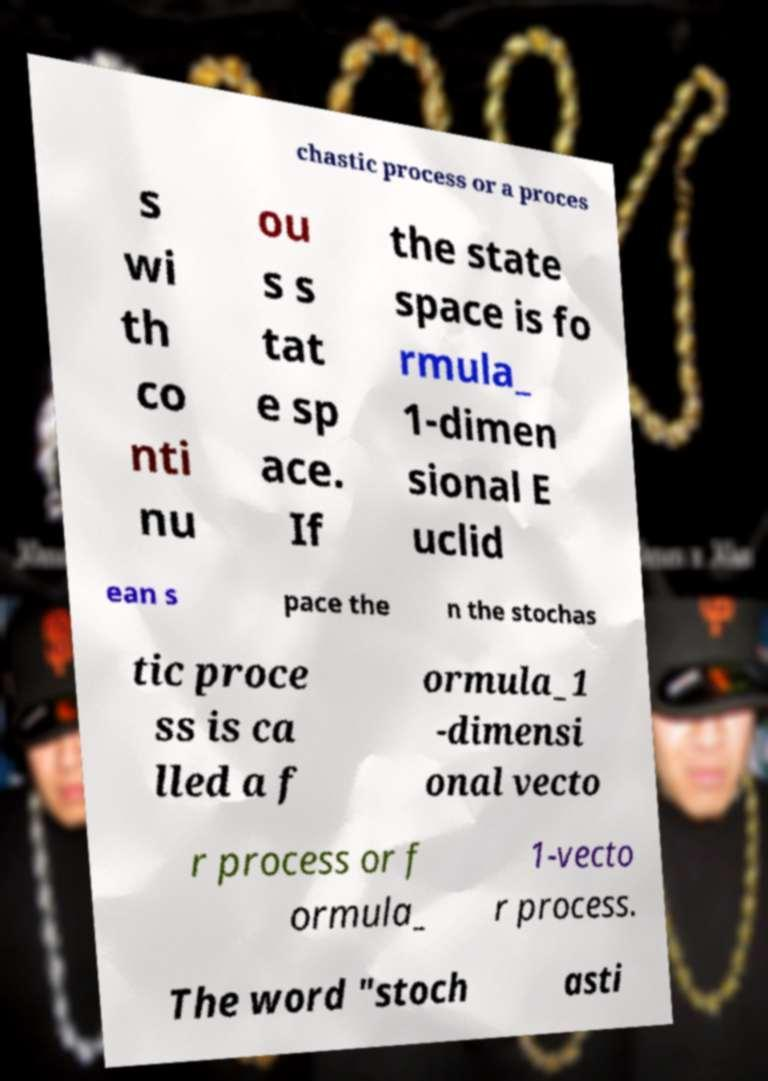For documentation purposes, I need the text within this image transcribed. Could you provide that? chastic process or a proces s wi th co nti nu ou s s tat e sp ace. If the state space is fo rmula_ 1-dimen sional E uclid ean s pace the n the stochas tic proce ss is ca lled a f ormula_1 -dimensi onal vecto r process or f ormula_ 1-vecto r process. The word "stoch asti 